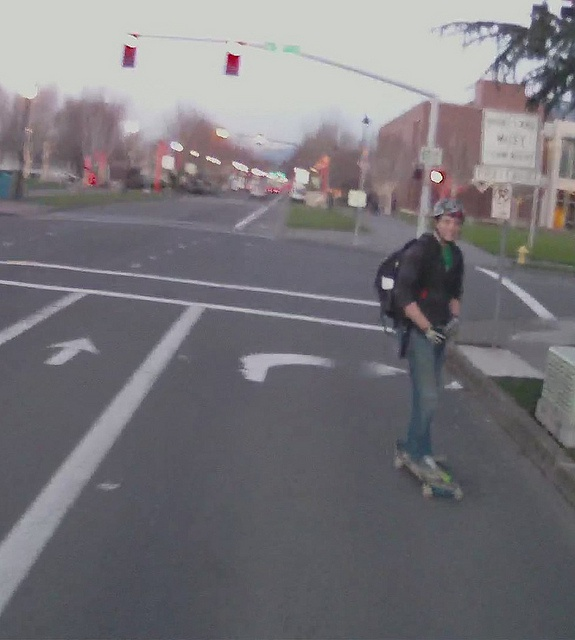Describe the objects in this image and their specific colors. I can see people in lightgray, gray, black, and blue tones, backpack in lightgray, gray, black, and darkgray tones, skateboard in lightgray, gray, blue, and black tones, traffic light in lightgray, purple, darkgray, and brown tones, and traffic light in lightgray, brown, gray, and maroon tones in this image. 